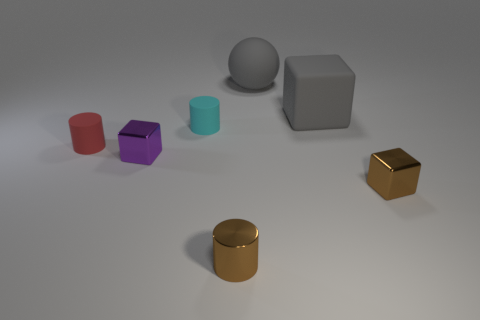Add 1 big gray cubes. How many objects exist? 8 Subtract all cylinders. How many objects are left? 4 Subtract 0 blue cylinders. How many objects are left? 7 Subtract all tiny green shiny blocks. Subtract all tiny brown objects. How many objects are left? 5 Add 7 gray spheres. How many gray spheres are left? 8 Add 6 brown metal cylinders. How many brown metal cylinders exist? 7 